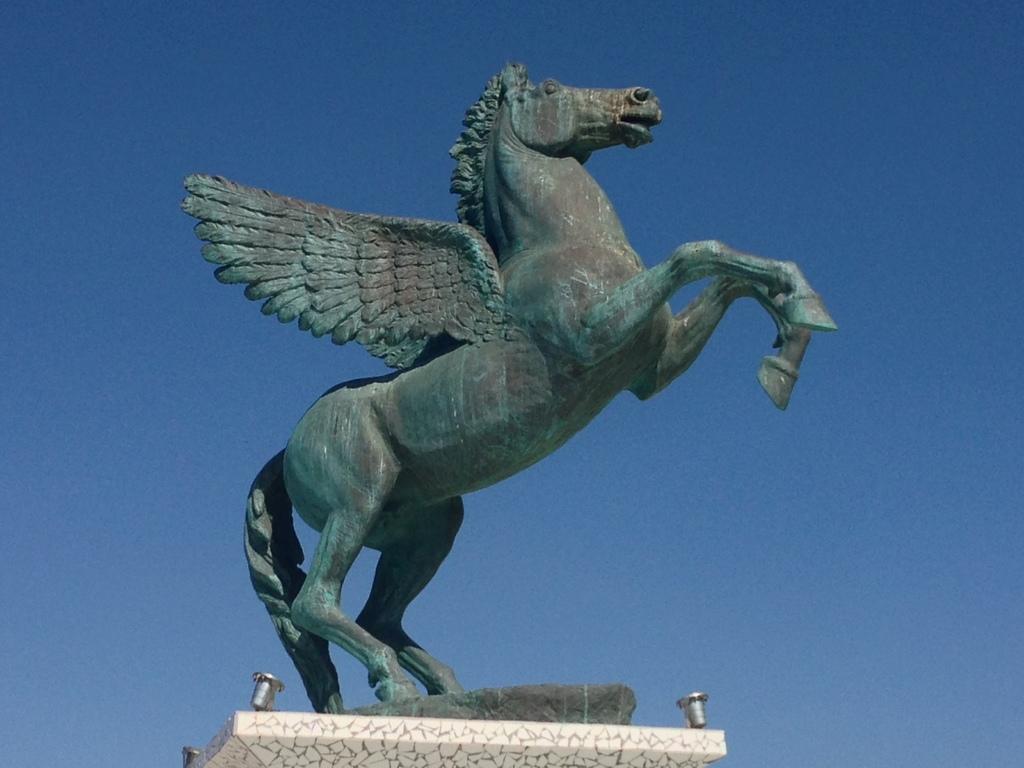In one or two sentences, can you explain what this image depicts? In this image we can see a statue and in the background, we can see the sky. 